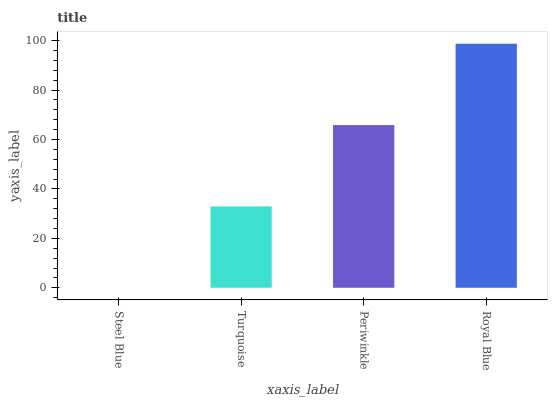Is Turquoise the minimum?
Answer yes or no. No. Is Turquoise the maximum?
Answer yes or no. No. Is Turquoise greater than Steel Blue?
Answer yes or no. Yes. Is Steel Blue less than Turquoise?
Answer yes or no. Yes. Is Steel Blue greater than Turquoise?
Answer yes or no. No. Is Turquoise less than Steel Blue?
Answer yes or no. No. Is Periwinkle the high median?
Answer yes or no. Yes. Is Turquoise the low median?
Answer yes or no. Yes. Is Royal Blue the high median?
Answer yes or no. No. Is Steel Blue the low median?
Answer yes or no. No. 